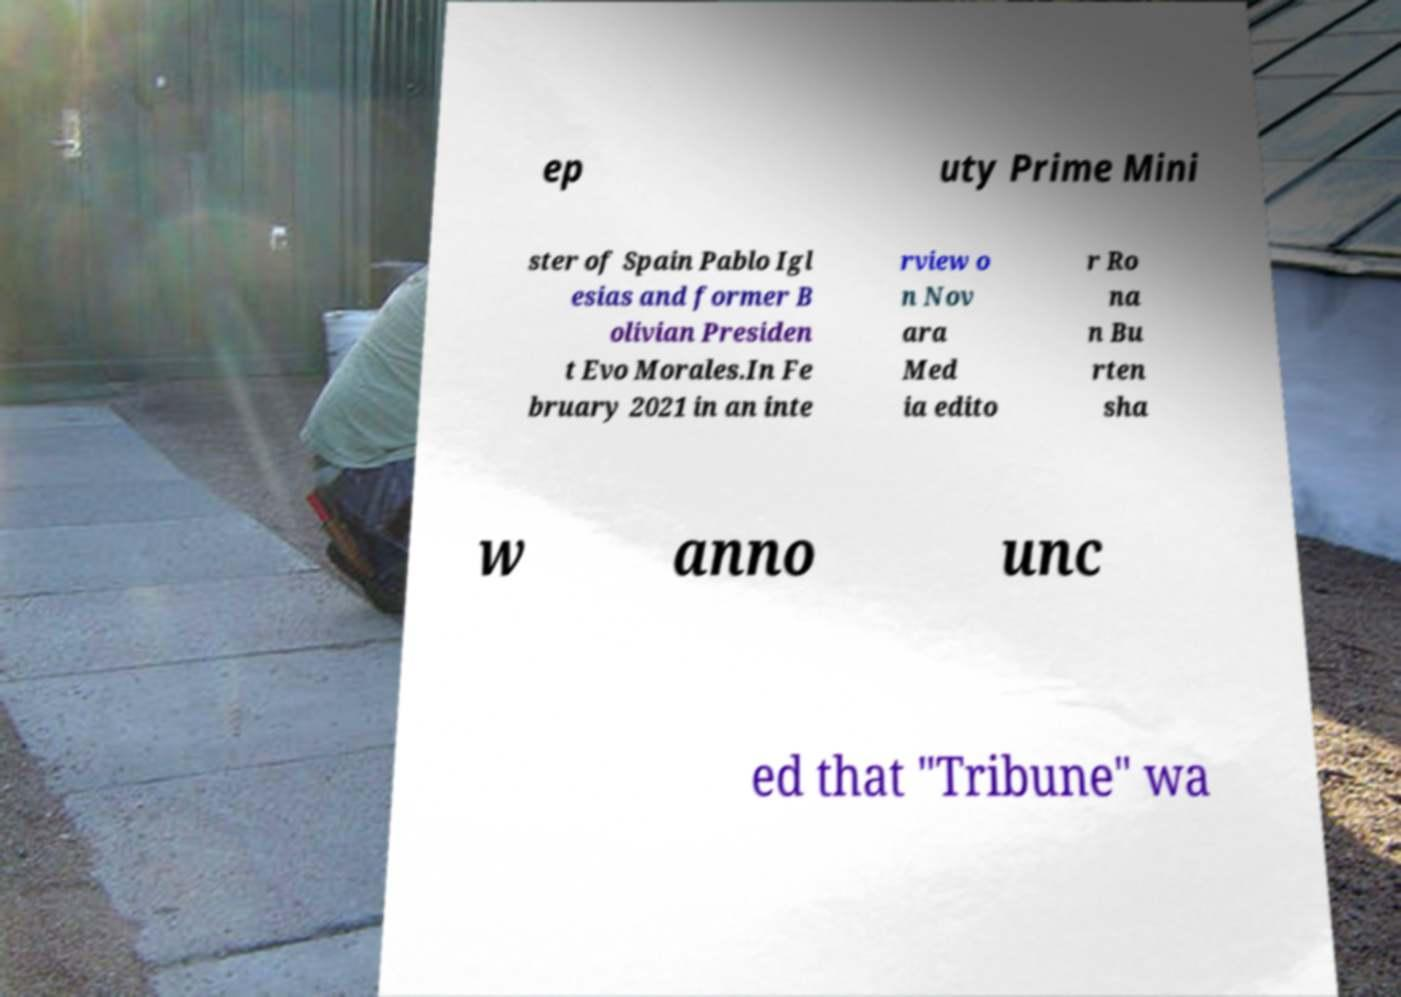Could you extract and type out the text from this image? ep uty Prime Mini ster of Spain Pablo Igl esias and former B olivian Presiden t Evo Morales.In Fe bruary 2021 in an inte rview o n Nov ara Med ia edito r Ro na n Bu rten sha w anno unc ed that "Tribune" wa 